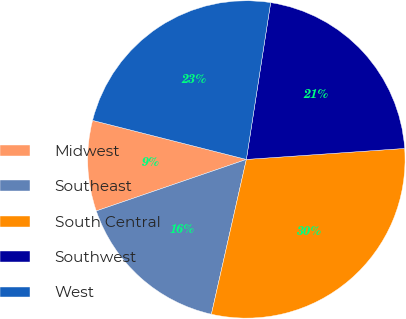Convert chart to OTSL. <chart><loc_0><loc_0><loc_500><loc_500><pie_chart><fcel>Midwest<fcel>Southeast<fcel>South Central<fcel>Southwest<fcel>West<nl><fcel>9.22%<fcel>16.2%<fcel>29.64%<fcel>21.45%<fcel>23.49%<nl></chart> 